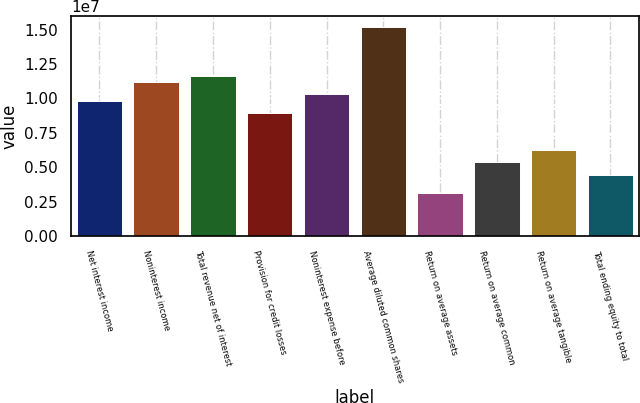Convert chart to OTSL. <chart><loc_0><loc_0><loc_500><loc_500><bar_chart><fcel>Net interest income<fcel>Noninterest income<fcel>Total revenue net of interest<fcel>Provision for credit losses<fcel>Noninterest expense before<fcel>Average diluted common shares<fcel>Return on average assets<fcel>Return on average common<fcel>Return on average tangible<fcel>Total ending equity to total<nl><fcel>9.84896e+06<fcel>1.1192e+07<fcel>1.16397e+07<fcel>8.9536e+06<fcel>1.02966e+07<fcel>1.52211e+07<fcel>3.13376e+06<fcel>5.37216e+06<fcel>6.26752e+06<fcel>4.4768e+06<nl></chart> 